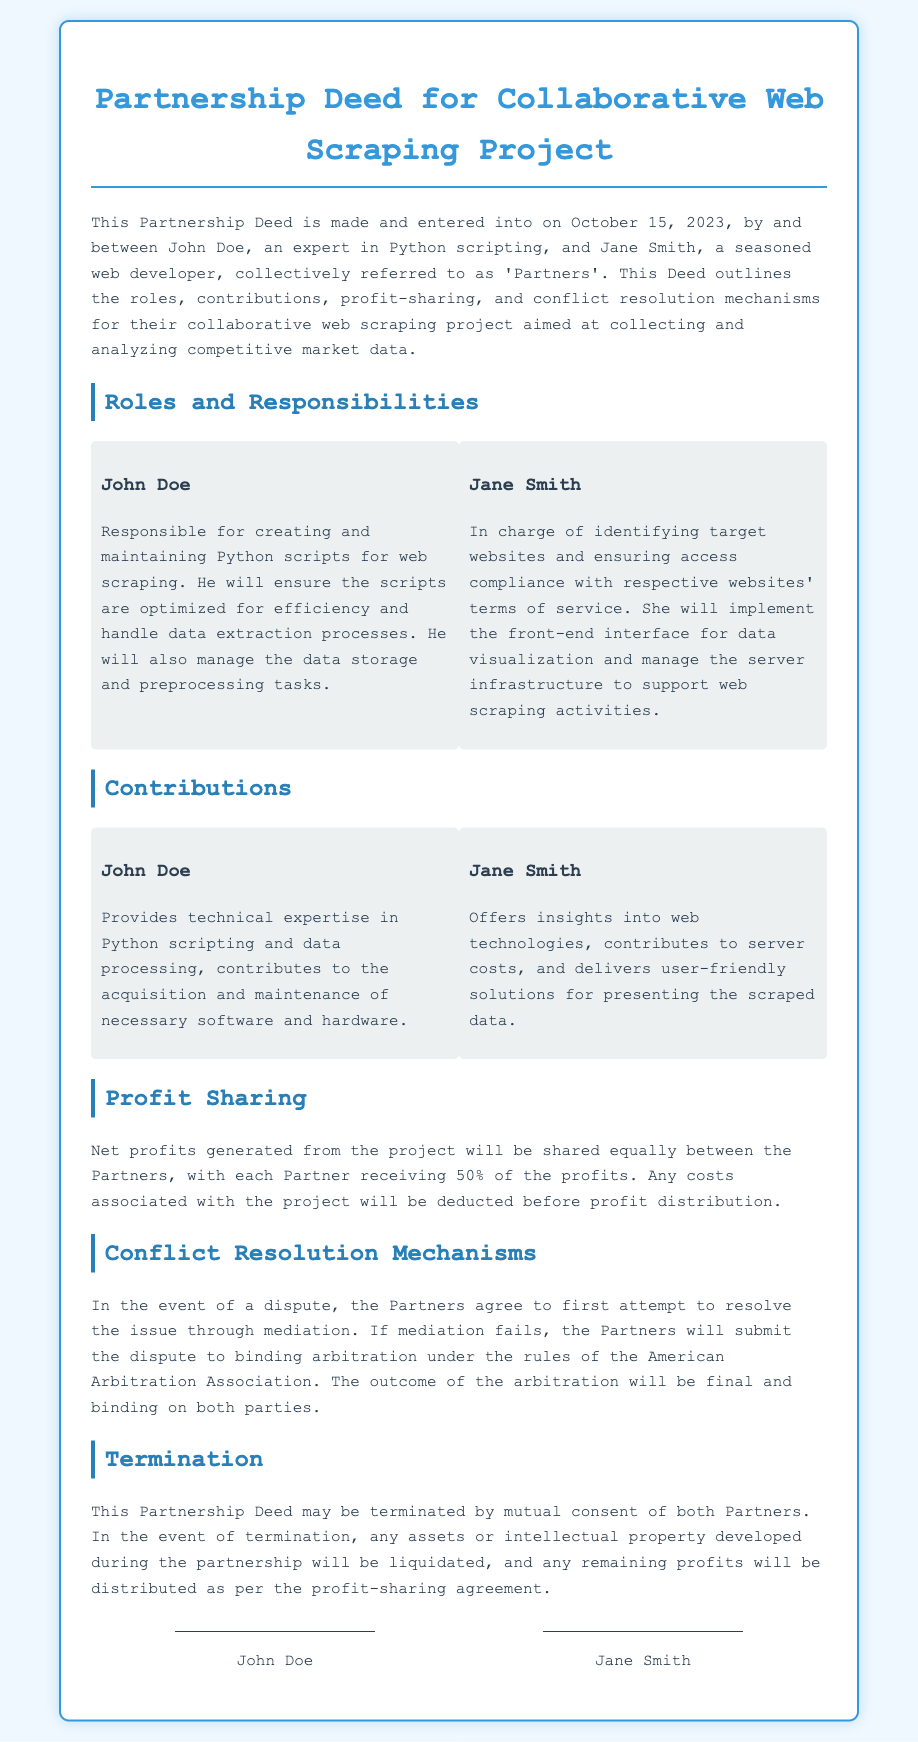What is the date of the Partnership Deed? The deed was made and entered into on October 15, 2023.
Answer: October 15, 2023 Who is responsible for creating and maintaining Python scripts? John Doe's role includes creating and maintaining Python scripts for web scraping.
Answer: John Doe What percentage of profits does each partner receive? Net profits are shared equally, so each partner receives 50% of the profits.
Answer: 50% What is Jane Smith's main responsibility related to websites? She is in charge of ensuring access compliance with respective websites' terms of service.
Answer: Access compliance What should partners do first in case of a dispute? The partners agree to attempt to resolve the issue through mediation.
Answer: Mediation How can the Partnership Deed be terminated? The Partnership Deed may be terminated by mutual consent of both partners.
Answer: Mutual consent What type of project is outlined in the Partnership Deed? The project is focused on collecting and analyzing competitive market data through web scraping.
Answer: Web scraping What will happen to assets upon termination of the Partnership Deed? Any assets or intellectual property will be liquidated upon termination.
Answer: Liquidated 